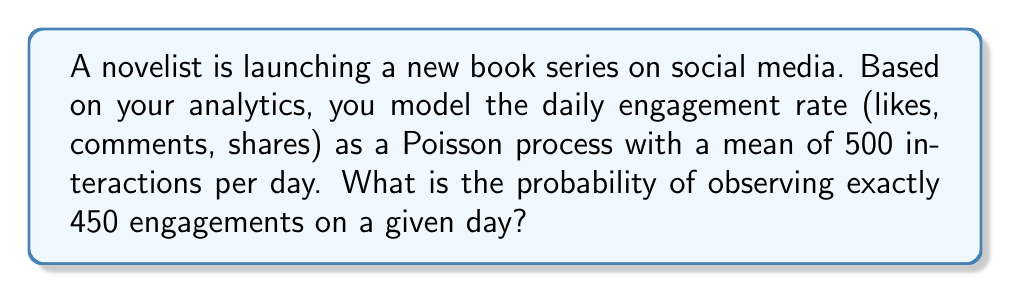Show me your answer to this math problem. To solve this problem, we'll use the Poisson distribution, which models the number of events occurring in a fixed interval of time when these events happen with a known average rate.

The Poisson probability mass function is given by:

$$P(X = k) = \frac{e^{-\lambda}\lambda^k}{k!}$$

Where:
- $\lambda$ is the average rate of events
- $k$ is the number of events we're interested in
- $e$ is Euler's number (approximately 2.71828)

Given:
- $\lambda = 500$ (mean interactions per day)
- $k = 450$ (exact number of engagements we're interested in)

Let's plug these values into the formula:

$$P(X = 450) = \frac{e^{-500}500^{450}}{450!}$$

To calculate this:

1. Compute $e^{-500}$
2. Calculate $500^{450}$
3. Determine $450!$
4. Multiply the results of steps 1 and 2
5. Divide the result by step 3

Using a calculator or computer (due to the large numbers involved):

$$P(X = 450) \approx 0.005196$$

This can be expressed as a percentage: 0.5196%
Answer: 0.005196 or 0.5196% 